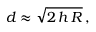<formula> <loc_0><loc_0><loc_500><loc_500>d \approx { \sqrt { 2 \, h \, R } } \, ,</formula> 